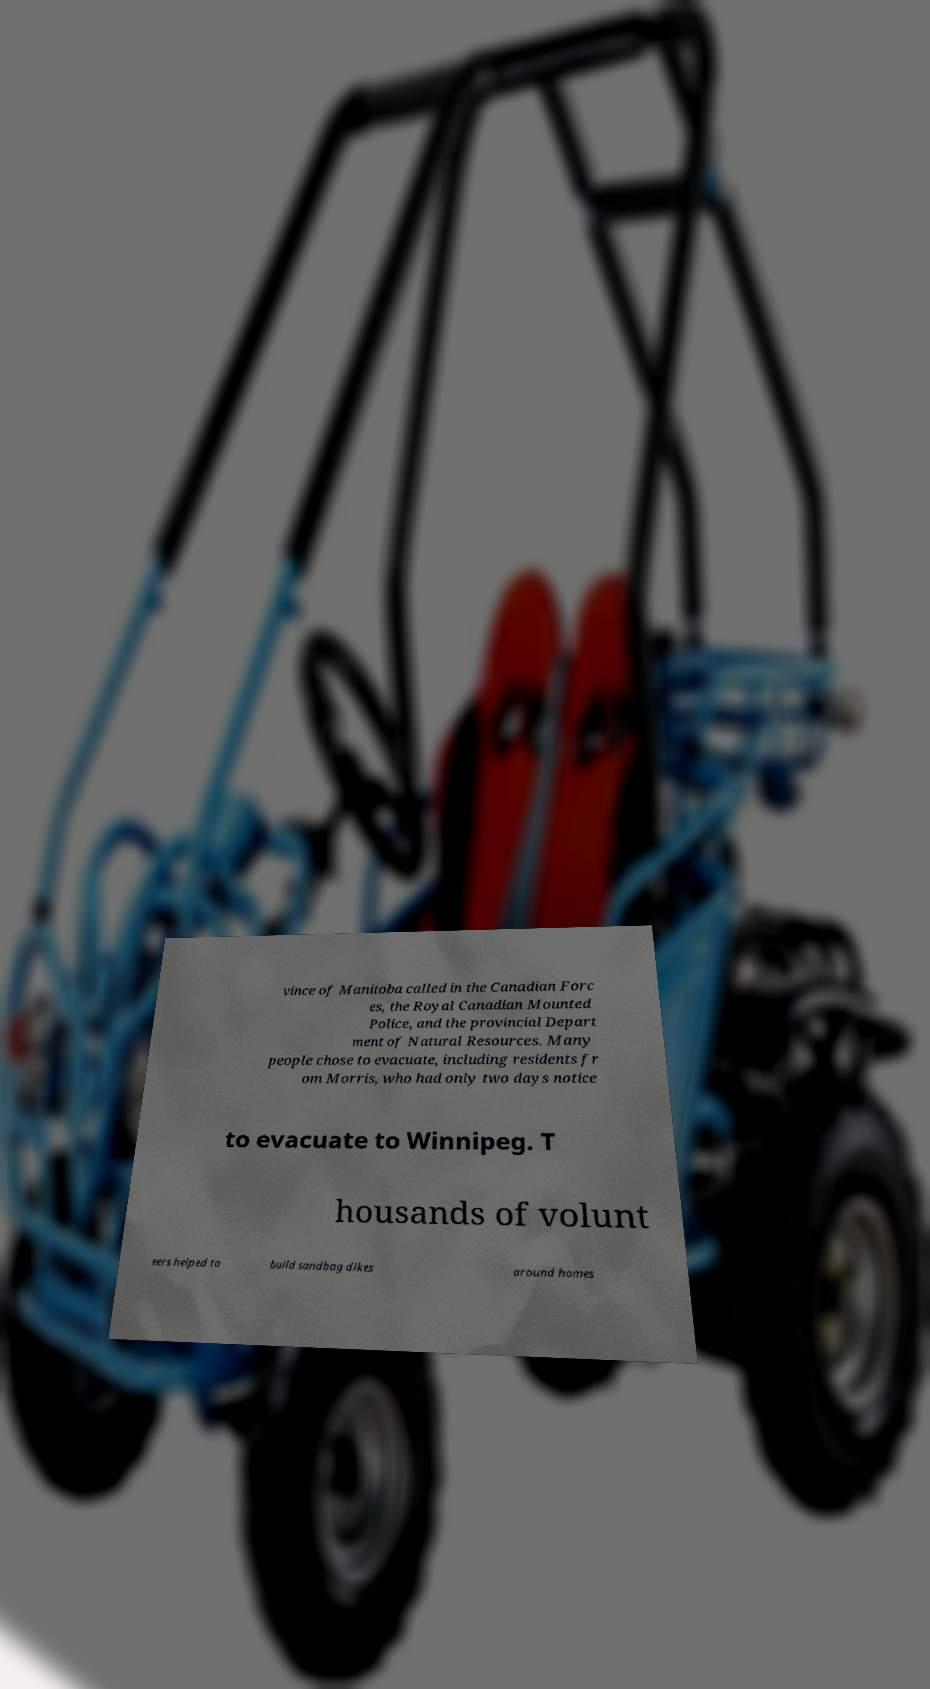Can you read and provide the text displayed in the image?This photo seems to have some interesting text. Can you extract and type it out for me? vince of Manitoba called in the Canadian Forc es, the Royal Canadian Mounted Police, and the provincial Depart ment of Natural Resources. Many people chose to evacuate, including residents fr om Morris, who had only two days notice to evacuate to Winnipeg. T housands of volunt eers helped to build sandbag dikes around homes 